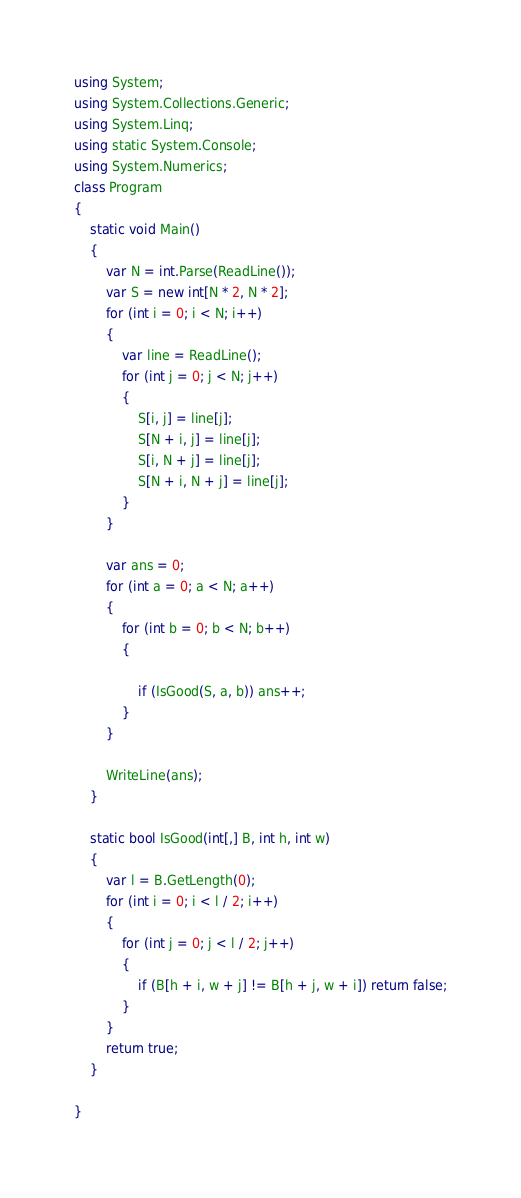<code> <loc_0><loc_0><loc_500><loc_500><_C#_>using System;
using System.Collections.Generic;
using System.Linq;
using static System.Console;
using System.Numerics;
class Program
{
    static void Main()
    {
        var N = int.Parse(ReadLine());
        var S = new int[N * 2, N * 2];
        for (int i = 0; i < N; i++)
        {
            var line = ReadLine();
            for (int j = 0; j < N; j++)
            {
                S[i, j] = line[j];
                S[N + i, j] = line[j];
                S[i, N + j] = line[j];
                S[N + i, N + j] = line[j];
            }
        }

        var ans = 0;
        for (int a = 0; a < N; a++)
        {
            for (int b = 0; b < N; b++)
            {

                if (IsGood(S, a, b)) ans++;
            }
        }

        WriteLine(ans);
    }

    static bool IsGood(int[,] B, int h, int w)
    {
        var l = B.GetLength(0);
        for (int i = 0; i < l / 2; i++)
        {
            for (int j = 0; j < l / 2; j++)
            {
                if (B[h + i, w + j] != B[h + j, w + i]) return false;
            }
        }
        return true;
    }

}</code> 